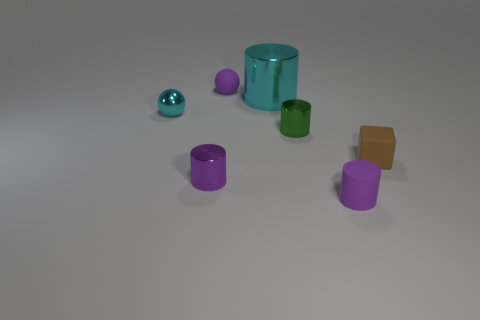Subtract all spheres. How many objects are left? 5 Add 1 small purple matte cylinders. How many small purple matte cylinders exist? 2 Add 1 matte cylinders. How many objects exist? 8 Subtract all purple balls. How many balls are left? 1 Subtract all green metal cylinders. How many cylinders are left? 3 Subtract 0 gray cylinders. How many objects are left? 7 Subtract 2 cylinders. How many cylinders are left? 2 Subtract all green cubes. Subtract all yellow balls. How many cubes are left? 1 Subtract all blue balls. How many purple cylinders are left? 2 Subtract all big objects. Subtract all small purple matte spheres. How many objects are left? 5 